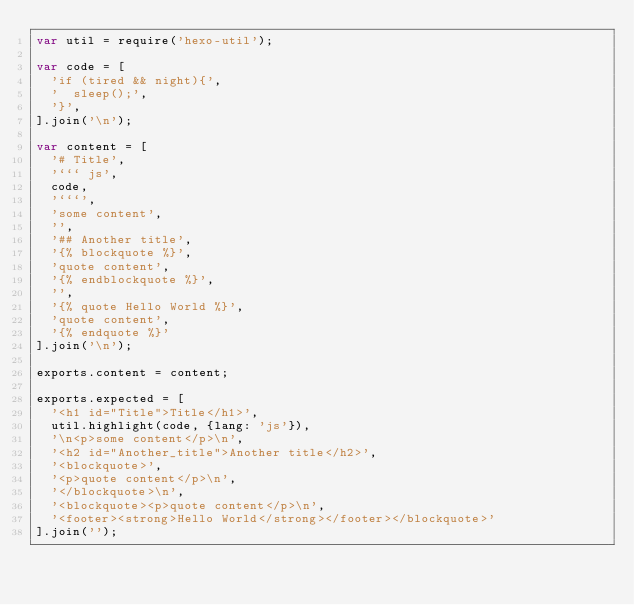Convert code to text. <code><loc_0><loc_0><loc_500><loc_500><_JavaScript_>var util = require('hexo-util');

var code = [
  'if (tired && night){',
  '  sleep();',
  '}',
].join('\n');

var content = [
  '# Title',
  '``` js',
  code,
  '```',
  'some content',
  '',
  '## Another title',
  '{% blockquote %}',
  'quote content',
  '{% endblockquote %}',
  '',
  '{% quote Hello World %}',
  'quote content',
  '{% endquote %}'
].join('\n');

exports.content = content;

exports.expected = [
  '<h1 id="Title">Title</h1>',
  util.highlight(code, {lang: 'js'}),
  '\n<p>some content</p>\n',
  '<h2 id="Another_title">Another title</h2>',
  '<blockquote>',
  '<p>quote content</p>\n',
  '</blockquote>\n',
  '<blockquote><p>quote content</p>\n',
  '<footer><strong>Hello World</strong></footer></blockquote>'
].join('');</code> 